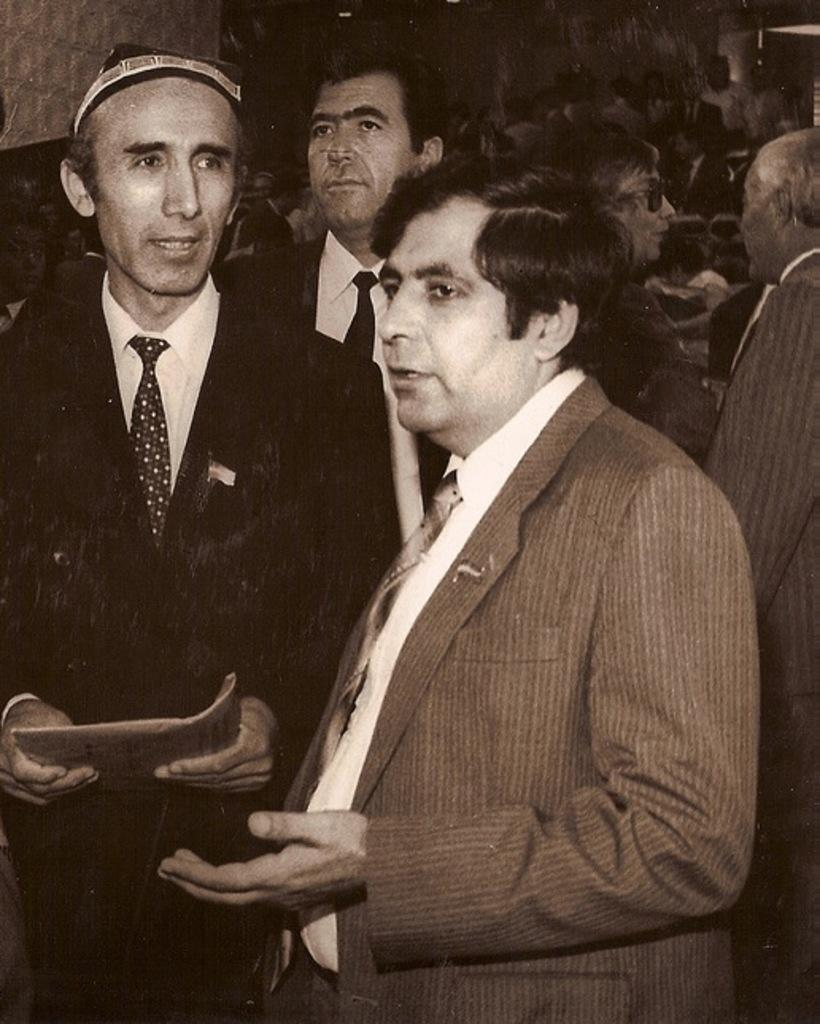What is happening in the foreground of the image? There are people in the foreground of the image, and they are talking. Can you describe what one person in the foreground is holding? One person in the foreground is holding something, but the specific object is not visible in the image. What can be seen in the background of the image? There is a group of people and objects in the background of the image. What plot is the aunt discussing with the group in the background? There is no aunt present in the image, and therefore no plot can be discussed. 